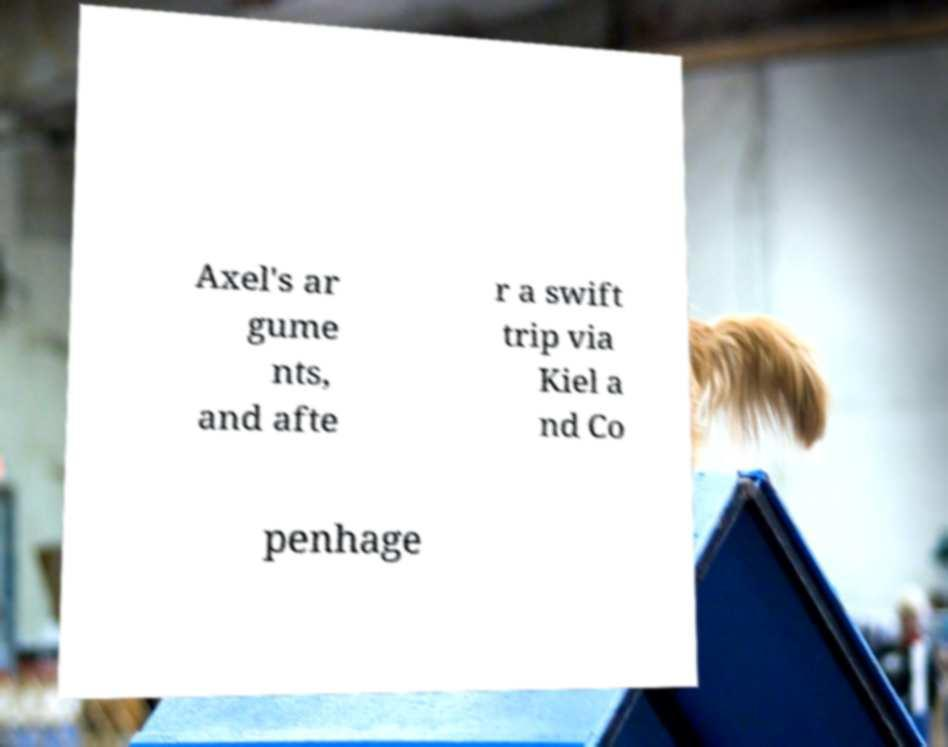Could you extract and type out the text from this image? Axel's ar gume nts, and afte r a swift trip via Kiel a nd Co penhage 